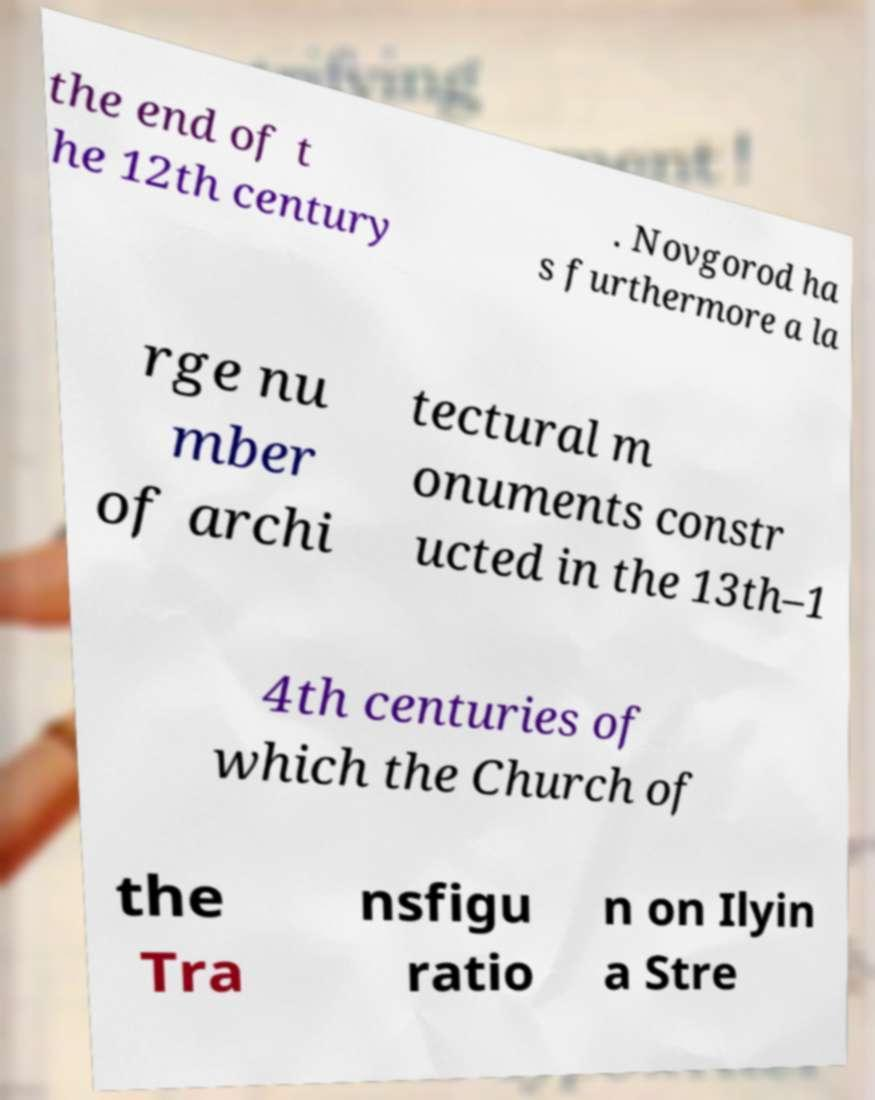Could you extract and type out the text from this image? the end of t he 12th century . Novgorod ha s furthermore a la rge nu mber of archi tectural m onuments constr ucted in the 13th–1 4th centuries of which the Church of the Tra nsfigu ratio n on Ilyin a Stre 